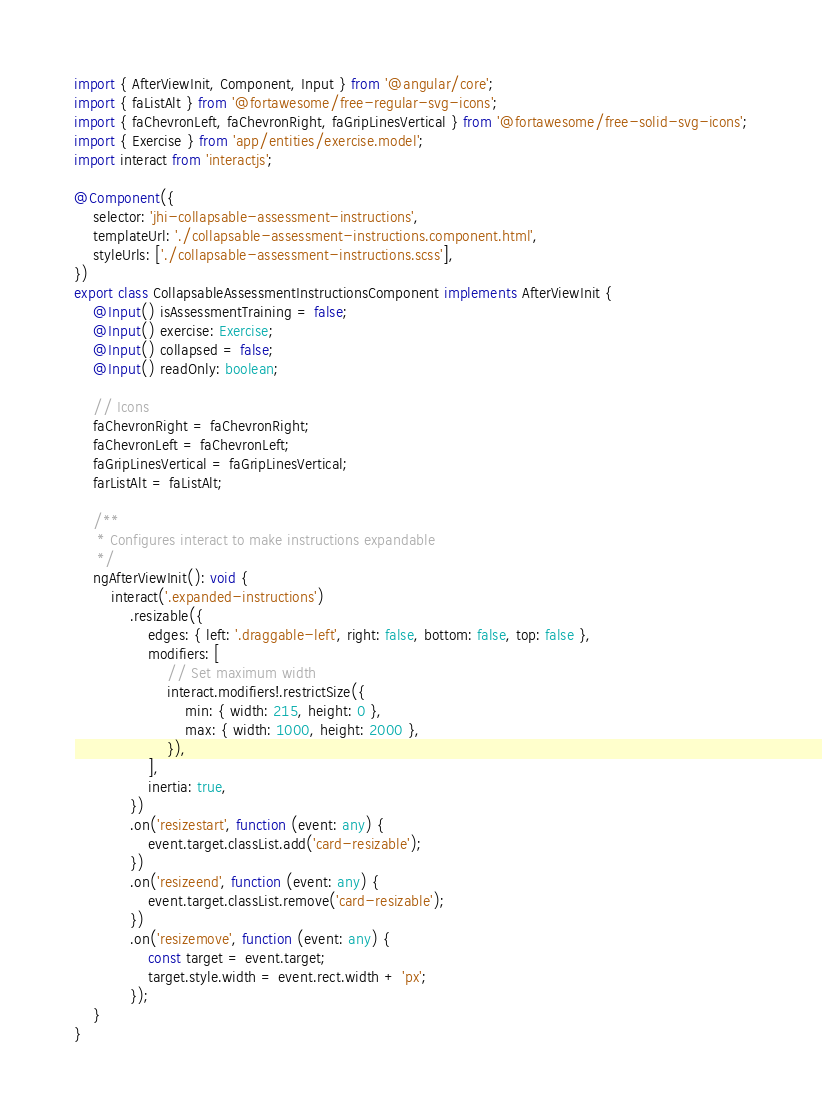<code> <loc_0><loc_0><loc_500><loc_500><_TypeScript_>import { AfterViewInit, Component, Input } from '@angular/core';
import { faListAlt } from '@fortawesome/free-regular-svg-icons';
import { faChevronLeft, faChevronRight, faGripLinesVertical } from '@fortawesome/free-solid-svg-icons';
import { Exercise } from 'app/entities/exercise.model';
import interact from 'interactjs';

@Component({
    selector: 'jhi-collapsable-assessment-instructions',
    templateUrl: './collapsable-assessment-instructions.component.html',
    styleUrls: ['./collapsable-assessment-instructions.scss'],
})
export class CollapsableAssessmentInstructionsComponent implements AfterViewInit {
    @Input() isAssessmentTraining = false;
    @Input() exercise: Exercise;
    @Input() collapsed = false;
    @Input() readOnly: boolean;

    // Icons
    faChevronRight = faChevronRight;
    faChevronLeft = faChevronLeft;
    faGripLinesVertical = faGripLinesVertical;
    farListAlt = faListAlt;

    /**
     * Configures interact to make instructions expandable
     */
    ngAfterViewInit(): void {
        interact('.expanded-instructions')
            .resizable({
                edges: { left: '.draggable-left', right: false, bottom: false, top: false },
                modifiers: [
                    // Set maximum width
                    interact.modifiers!.restrictSize({
                        min: { width: 215, height: 0 },
                        max: { width: 1000, height: 2000 },
                    }),
                ],
                inertia: true,
            })
            .on('resizestart', function (event: any) {
                event.target.classList.add('card-resizable');
            })
            .on('resizeend', function (event: any) {
                event.target.classList.remove('card-resizable');
            })
            .on('resizemove', function (event: any) {
                const target = event.target;
                target.style.width = event.rect.width + 'px';
            });
    }
}
</code> 